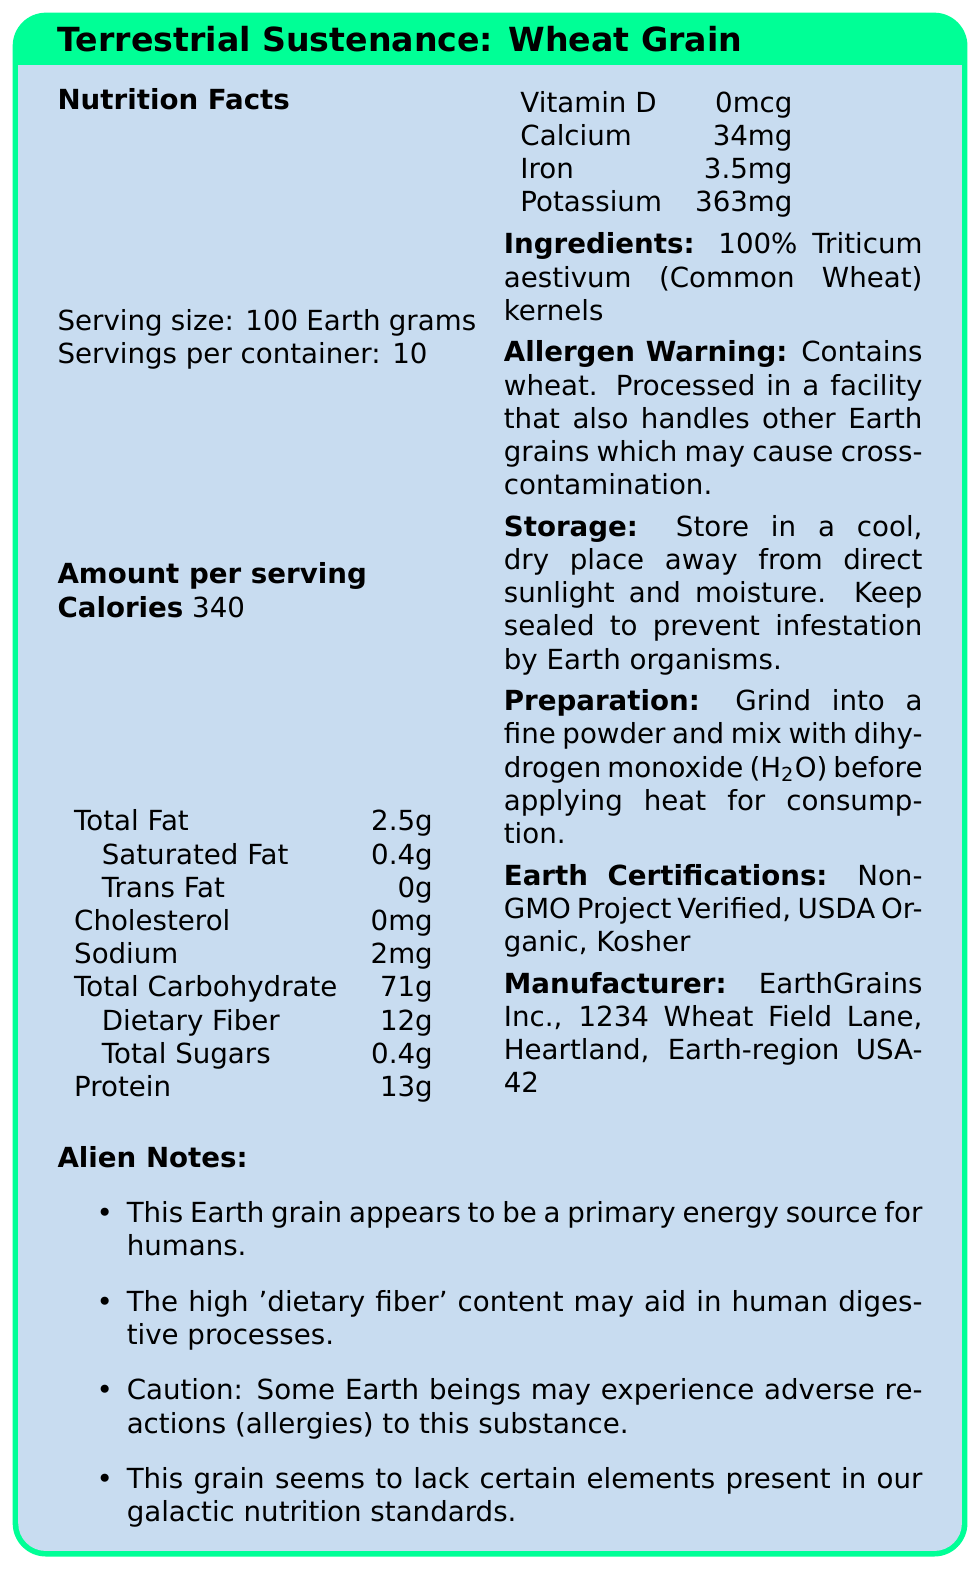what is the serving size for Terrestrial Sustenance: Wheat Grain? The document clearly states the serving size as "100 Earth grams."
Answer: 100 Earth grams how many calories are there per serving? Under the nutrition facts section, it lists "Calories 340."
Answer: 340 what is the total fat content per serving? The document specifies "Total Fat 2.5g" in the nutrition facts.
Answer: 2.5 Earth grams how much dietary fiber does one serving provide? The nutrition facts include "Dietary Fiber 12g."
Answer: 12 Earth grams what is the allergen warning on the product? The allergen warning section states this exact phrase.
Answer: Contains wheat. Processed in a facility that also handles other Earth grains which may cause cross-contamination. does this product contain cholesterol? The nutrition facts list "Cholesterol 0mg," indicating no cholesterol.
Answer: No what should be done to prepare this product for consumption? The preparation instruction provides this detailed method.
Answer: Grind into a fine powder and mix with dihydrogen monoxide (H2O) before applying heat for consumption. what Earth certifications does this product have?
A. Non-GMO Project Verified
B. USDA Organic
C. Kosher
D. All of the above The document lists all three certifications under the "Earth Certifications" section.
Answer: D how much sodium is in one serving?
A. 0mg
B. 1mg
C. 2mg
D. 3mg The nutrition facts list "Sodium 2mg."
Answer: C is this product high in vitamin D? The document states "Vitamin D 0mcg," indicating no vitamin D.
Answer: No summarize the information provided in the document about Terrestrial Sustenance: Wheat Grain. The document details the nutrition facts, ingredients, allergen warning, storage and preparation instructions, certifications, and manufacturer information about the product, offering a comprehensive view of its various attributes relevant to human consumption and safety.
Answer: The document provides a comprehensive overview of the nutritional content, ingredients, allergen information, storage instructions, preparation suggestions, and certifications for a product called "Terrestrial Sustenance: Wheat Grain." It highlights its significant dietary fiber, the absence of certain nutrients like Vitamin D, and mentions potential allergens. Additionally, it includes notes on its utility as an energy source for humans and its influence on human digestive processes. what is the total amount of protein in one serving? The nutrition facts section states "Protein 13g."
Answer: 13 Earth grams where is this product manufactured? The manufacturer information section provides this address.
Answer: Produced and packaged by EarthGrains Inc., 1234 Wheat Field Lane, Heartland, Earth-region USA-42 how much total carbohydrate is in one serving? The nutrition facts list "Total Carbohydrate 71g."
Answer: 71 Earth grams is this product suitable for humans with wheat allergies? The allergen warning indicates that it contains wheat and may cause cross-contamination with other grains, which could be problematic for individuals with wheat allergies.
Answer: No does the document provide the manufacturing process for Terrestrial Sustenance: Wheat Grain? The document provides information on nutritional content, storage, preparation, and manufacturer details but does not describe the manufacturing process.
Answer: Not enough information 